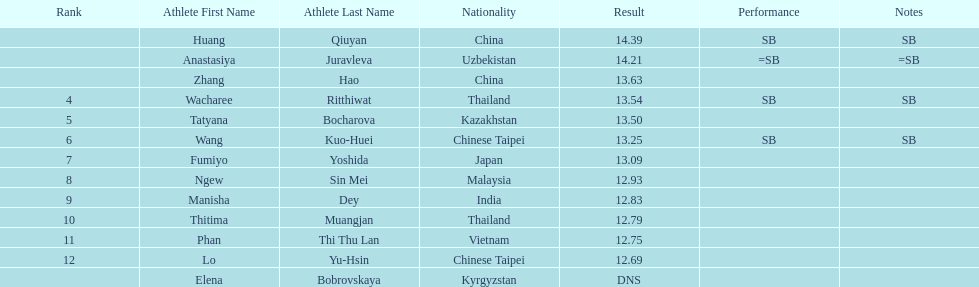How many points apart were the 1st place competitor and the 12th place competitor? 1.7. 